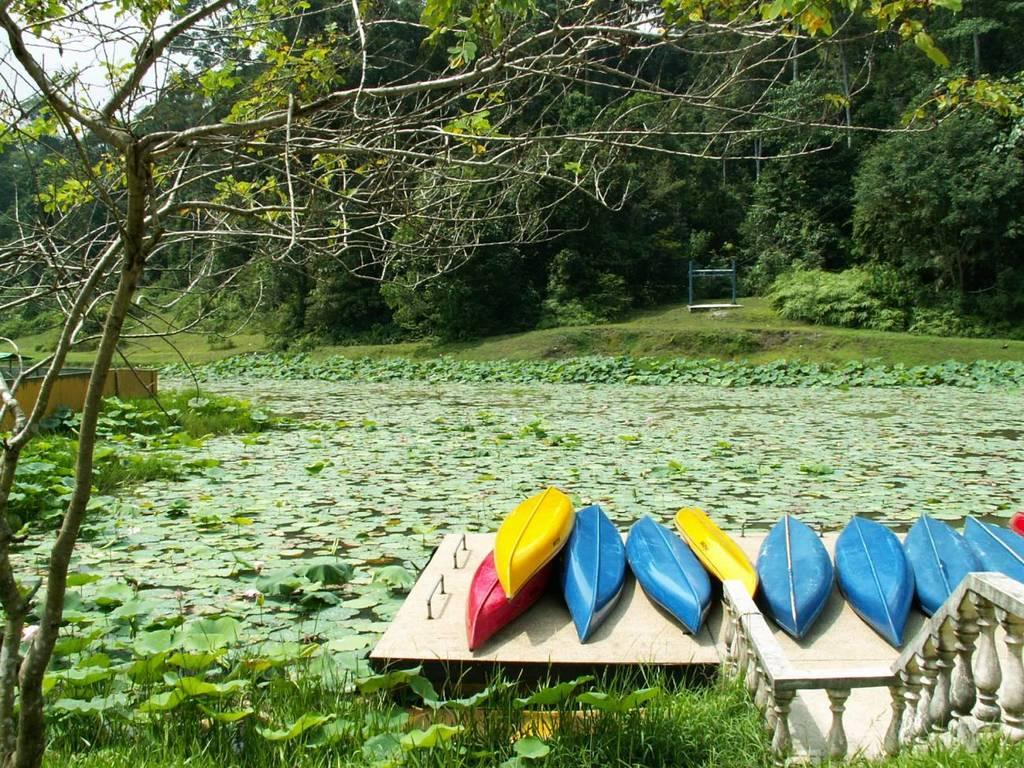Can you describe this image briefly? On the right side of the picture, we see skiffs which are in yellow, blue and red color. At the bottom of the picture, we see grass and plants. We see water and lotus leaves in the water. On the left side, we see a tree. There are many trees in the background. 